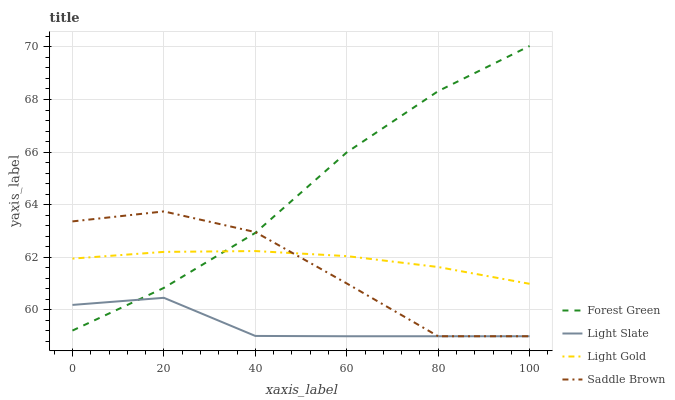Does Light Slate have the minimum area under the curve?
Answer yes or no. Yes. Does Forest Green have the maximum area under the curve?
Answer yes or no. Yes. Does Light Gold have the minimum area under the curve?
Answer yes or no. No. Does Light Gold have the maximum area under the curve?
Answer yes or no. No. Is Light Gold the smoothest?
Answer yes or no. Yes. Is Saddle Brown the roughest?
Answer yes or no. Yes. Is Forest Green the smoothest?
Answer yes or no. No. Is Forest Green the roughest?
Answer yes or no. No. Does Light Slate have the lowest value?
Answer yes or no. Yes. Does Forest Green have the lowest value?
Answer yes or no. No. Does Forest Green have the highest value?
Answer yes or no. Yes. Does Light Gold have the highest value?
Answer yes or no. No. Is Light Slate less than Light Gold?
Answer yes or no. Yes. Is Light Gold greater than Light Slate?
Answer yes or no. Yes. Does Forest Green intersect Light Gold?
Answer yes or no. Yes. Is Forest Green less than Light Gold?
Answer yes or no. No. Is Forest Green greater than Light Gold?
Answer yes or no. No. Does Light Slate intersect Light Gold?
Answer yes or no. No. 